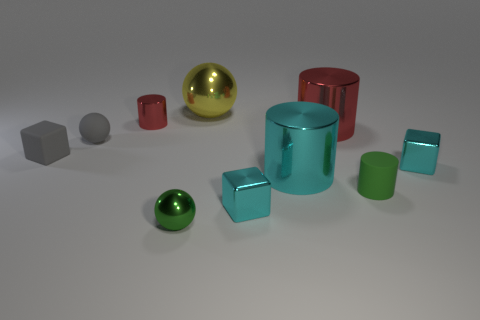Subtract all big cyan cylinders. How many cylinders are left? 3 Subtract all cylinders. How many objects are left? 6 Subtract 2 cylinders. How many cylinders are left? 2 Subtract all cyan cylinders. How many cylinders are left? 3 Subtract all red balls. How many gray blocks are left? 1 Subtract all large purple rubber balls. Subtract all tiny metal balls. How many objects are left? 9 Add 7 gray rubber objects. How many gray rubber objects are left? 9 Add 1 small red objects. How many small red objects exist? 2 Subtract 0 gray cylinders. How many objects are left? 10 Subtract all green cubes. Subtract all red spheres. How many cubes are left? 3 